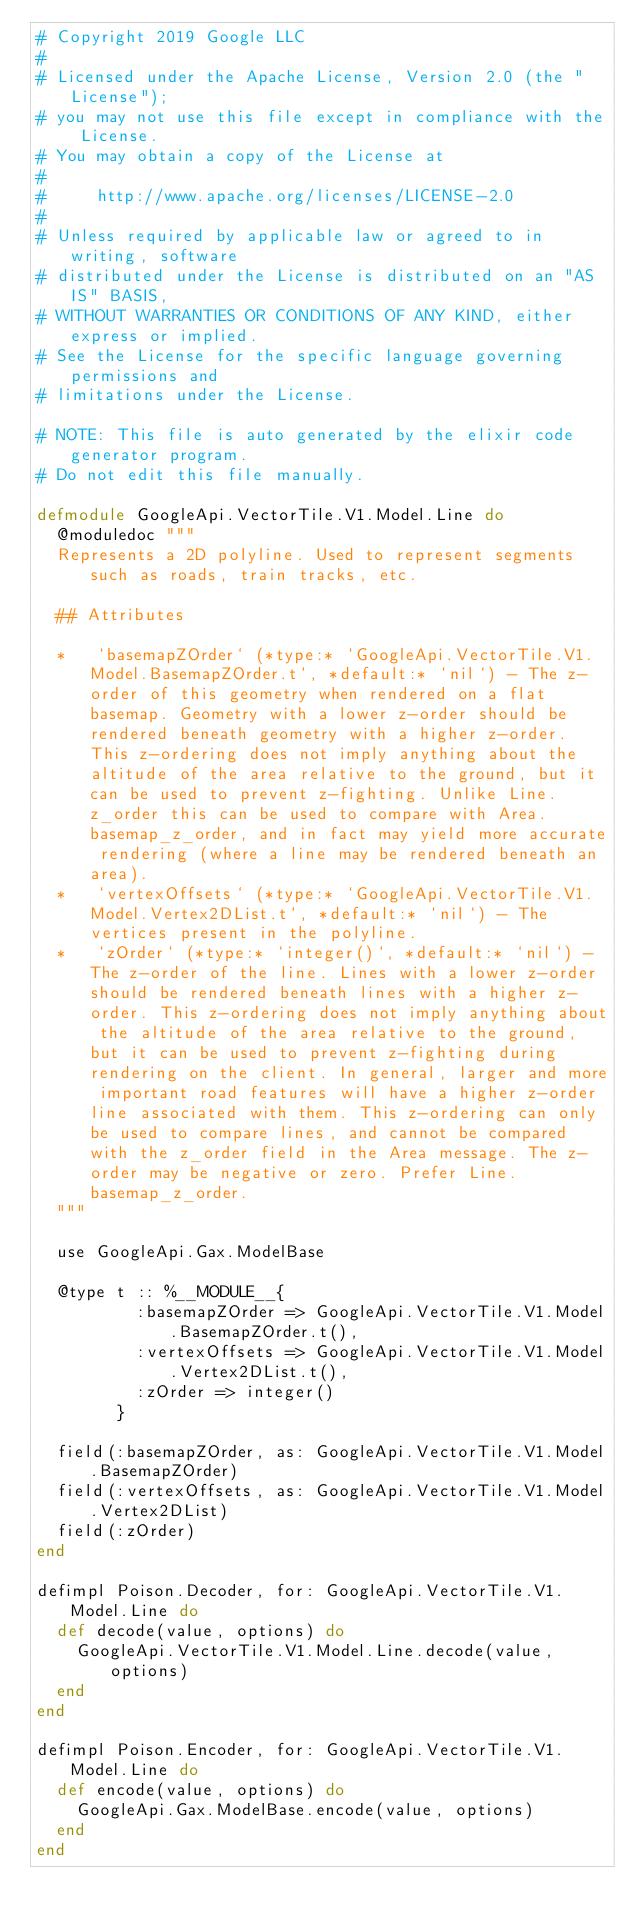<code> <loc_0><loc_0><loc_500><loc_500><_Elixir_># Copyright 2019 Google LLC
#
# Licensed under the Apache License, Version 2.0 (the "License");
# you may not use this file except in compliance with the License.
# You may obtain a copy of the License at
#
#     http://www.apache.org/licenses/LICENSE-2.0
#
# Unless required by applicable law or agreed to in writing, software
# distributed under the License is distributed on an "AS IS" BASIS,
# WITHOUT WARRANTIES OR CONDITIONS OF ANY KIND, either express or implied.
# See the License for the specific language governing permissions and
# limitations under the License.

# NOTE: This file is auto generated by the elixir code generator program.
# Do not edit this file manually.

defmodule GoogleApi.VectorTile.V1.Model.Line do
  @moduledoc """
  Represents a 2D polyline. Used to represent segments such as roads, train tracks, etc.

  ## Attributes

  *   `basemapZOrder` (*type:* `GoogleApi.VectorTile.V1.Model.BasemapZOrder.t`, *default:* `nil`) - The z-order of this geometry when rendered on a flat basemap. Geometry with a lower z-order should be rendered beneath geometry with a higher z-order. This z-ordering does not imply anything about the altitude of the area relative to the ground, but it can be used to prevent z-fighting. Unlike Line.z_order this can be used to compare with Area.basemap_z_order, and in fact may yield more accurate rendering (where a line may be rendered beneath an area).
  *   `vertexOffsets` (*type:* `GoogleApi.VectorTile.V1.Model.Vertex2DList.t`, *default:* `nil`) - The vertices present in the polyline.
  *   `zOrder` (*type:* `integer()`, *default:* `nil`) - The z-order of the line. Lines with a lower z-order should be rendered beneath lines with a higher z-order. This z-ordering does not imply anything about the altitude of the area relative to the ground, but it can be used to prevent z-fighting during rendering on the client. In general, larger and more important road features will have a higher z-order line associated with them. This z-ordering can only be used to compare lines, and cannot be compared with the z_order field in the Area message. The z-order may be negative or zero. Prefer Line.basemap_z_order.
  """

  use GoogleApi.Gax.ModelBase

  @type t :: %__MODULE__{
          :basemapZOrder => GoogleApi.VectorTile.V1.Model.BasemapZOrder.t(),
          :vertexOffsets => GoogleApi.VectorTile.V1.Model.Vertex2DList.t(),
          :zOrder => integer()
        }

  field(:basemapZOrder, as: GoogleApi.VectorTile.V1.Model.BasemapZOrder)
  field(:vertexOffsets, as: GoogleApi.VectorTile.V1.Model.Vertex2DList)
  field(:zOrder)
end

defimpl Poison.Decoder, for: GoogleApi.VectorTile.V1.Model.Line do
  def decode(value, options) do
    GoogleApi.VectorTile.V1.Model.Line.decode(value, options)
  end
end

defimpl Poison.Encoder, for: GoogleApi.VectorTile.V1.Model.Line do
  def encode(value, options) do
    GoogleApi.Gax.ModelBase.encode(value, options)
  end
end
</code> 